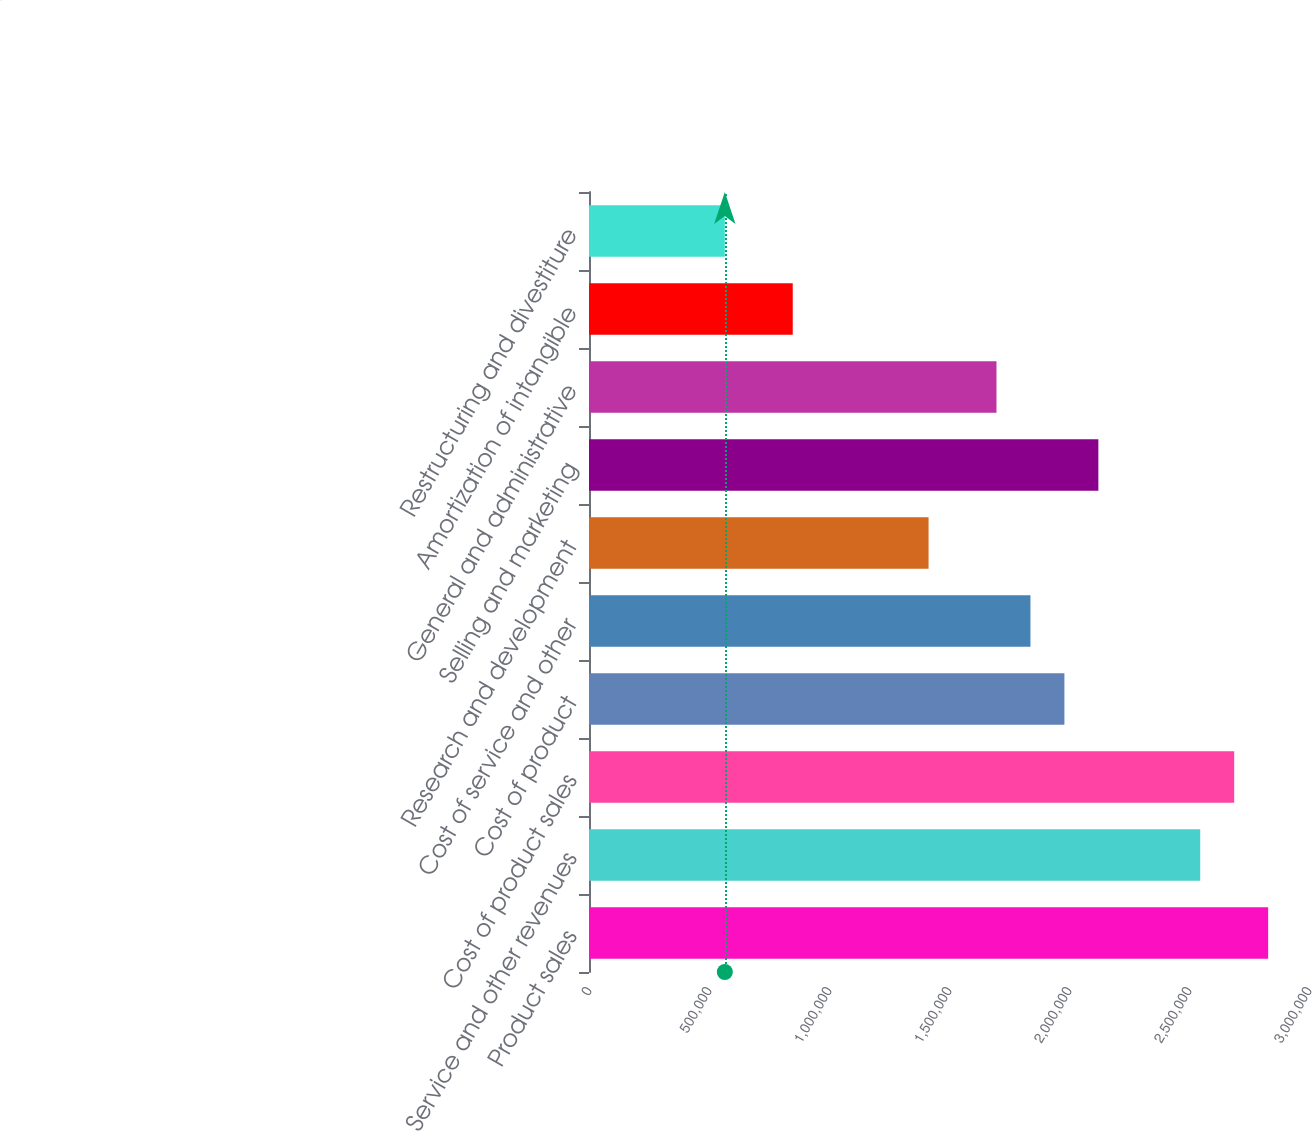<chart> <loc_0><loc_0><loc_500><loc_500><bar_chart><fcel>Product sales<fcel>Service and other revenues<fcel>Cost of product sales<fcel>Cost of product<fcel>Cost of service and other<fcel>Research and development<fcel>Selling and marketing<fcel>General and administrative<fcel>Amortization of intangible<fcel>Restructuring and divestiture<nl><fcel>2.8298e+06<fcel>2.54682e+06<fcel>2.68831e+06<fcel>1.98086e+06<fcel>1.83937e+06<fcel>1.4149e+06<fcel>2.12235e+06<fcel>1.69788e+06<fcel>848940<fcel>565960<nl></chart> 